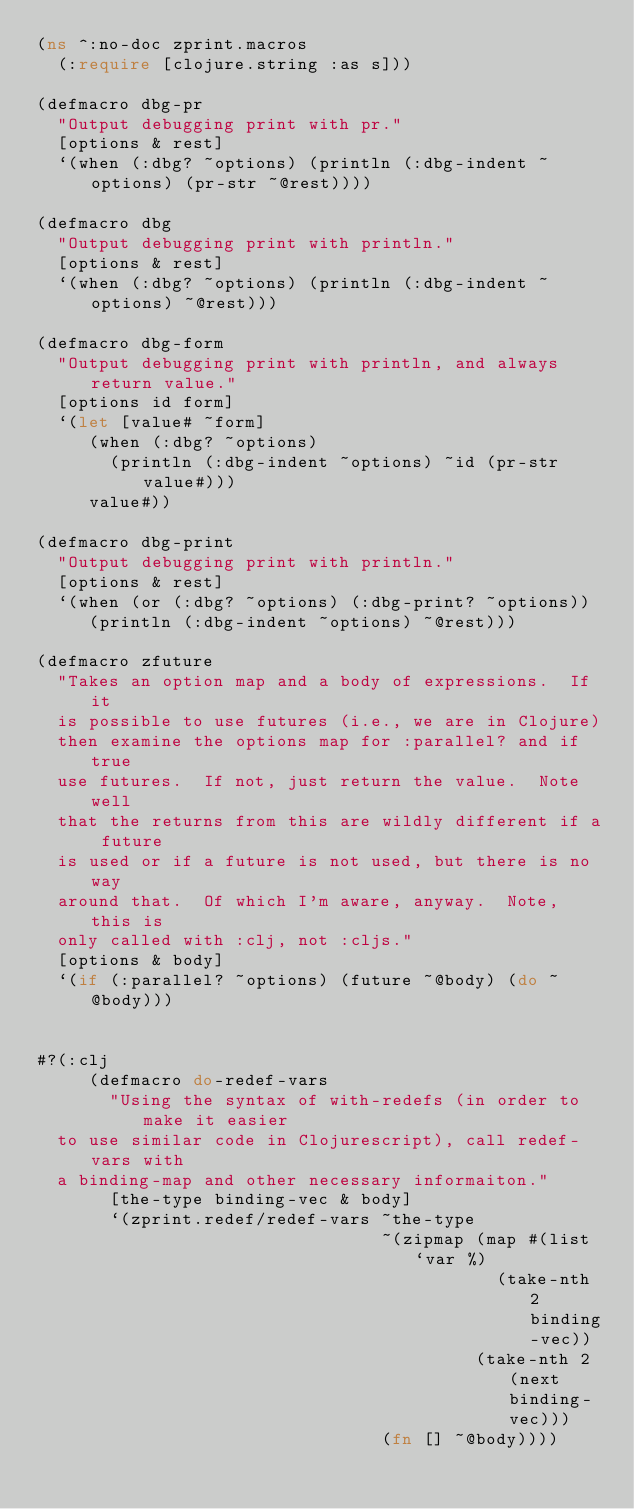Convert code to text. <code><loc_0><loc_0><loc_500><loc_500><_Clojure_>(ns ^:no-doc zprint.macros
  (:require [clojure.string :as s]))

(defmacro dbg-pr
  "Output debugging print with pr."
  [options & rest]
  `(when (:dbg? ~options) (println (:dbg-indent ~options) (pr-str ~@rest))))

(defmacro dbg
  "Output debugging print with println."
  [options & rest]
  `(when (:dbg? ~options) (println (:dbg-indent ~options) ~@rest)))

(defmacro dbg-form
  "Output debugging print with println, and always return value."
  [options id form]
  `(let [value# ~form]
     (when (:dbg? ~options)
       (println (:dbg-indent ~options) ~id (pr-str value#)))
     value#))

(defmacro dbg-print
  "Output debugging print with println."
  [options & rest]
  `(when (or (:dbg? ~options) (:dbg-print? ~options))
     (println (:dbg-indent ~options) ~@rest)))

(defmacro zfuture
  "Takes an option map and a body of expressions.  If it
  is possible to use futures (i.e., we are in Clojure)
  then examine the options map for :parallel? and if true
  use futures.  If not, just return the value.  Note well
  that the returns from this are wildly different if a future
  is used or if a future is not used, but there is no way
  around that.  Of which I'm aware, anyway.  Note, this is
  only called with :clj, not :cljs."
  [options & body]
  `(if (:parallel? ~options) (future ~@body) (do ~@body)))


#?(:clj
     (defmacro do-redef-vars
       "Using the syntax of with-redefs (in order to make it easier
  to use similar code in Clojurescript), call redef-vars with
  a binding-map and other necessary informaiton."
       [the-type binding-vec & body]
       `(zprint.redef/redef-vars ~the-type
                                 ~(zipmap (map #(list `var %)
                                            (take-nth 2 binding-vec))
                                          (take-nth 2 (next binding-vec)))
                                 (fn [] ~@body))))
</code> 